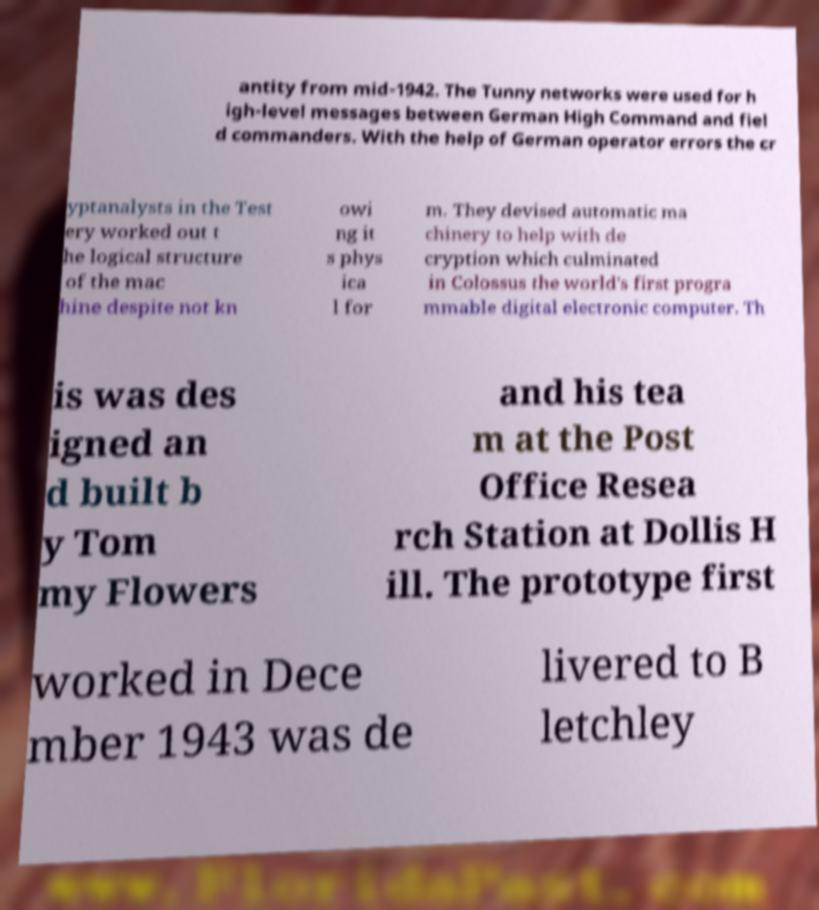What messages or text are displayed in this image? I need them in a readable, typed format. antity from mid-1942. The Tunny networks were used for h igh-level messages between German High Command and fiel d commanders. With the help of German operator errors the cr yptanalysts in the Test ery worked out t he logical structure of the mac hine despite not kn owi ng it s phys ica l for m. They devised automatic ma chinery to help with de cryption which culminated in Colossus the world's first progra mmable digital electronic computer. Th is was des igned an d built b y Tom my Flowers and his tea m at the Post Office Resea rch Station at Dollis H ill. The prototype first worked in Dece mber 1943 was de livered to B letchley 